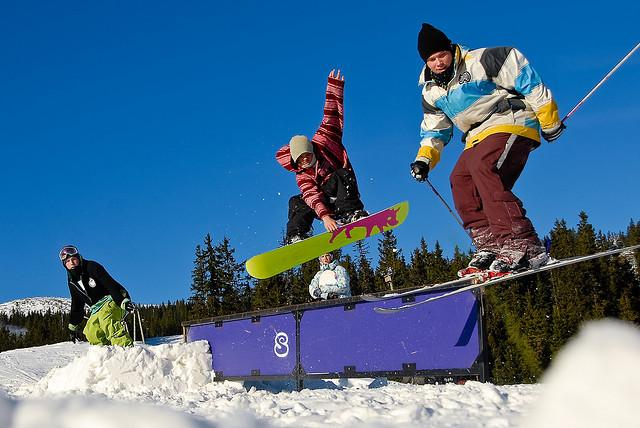What is the black hat the man is wearing called?

Choices:
A) top hat
B) derby
C) beanie
D) fedora beanie 